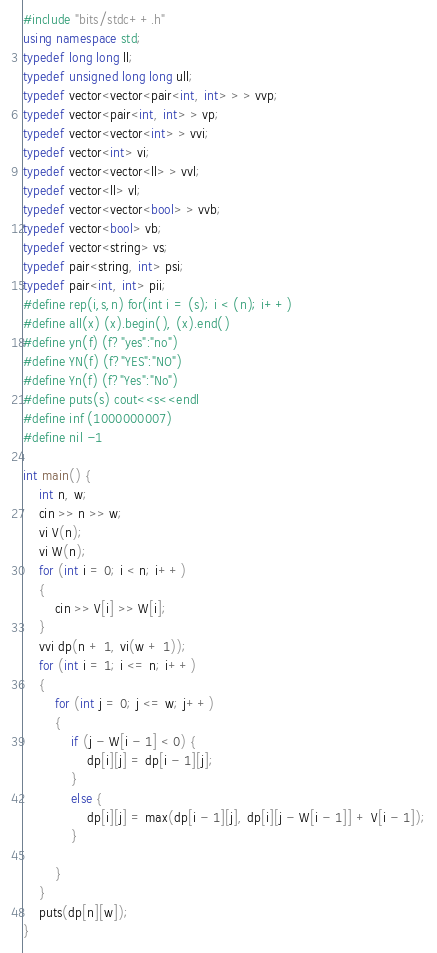Convert code to text. <code><loc_0><loc_0><loc_500><loc_500><_C++_>#include "bits/stdc++.h"
using namespace std;
typedef long long ll;
typedef unsigned long long ull;
typedef vector<vector<pair<int, int> > > vvp;
typedef vector<pair<int, int> > vp;
typedef vector<vector<int> > vvi;
typedef vector<int> vi;
typedef vector<vector<ll> > vvl;
typedef vector<ll> vl;
typedef vector<vector<bool> > vvb;
typedef vector<bool> vb;
typedef vector<string> vs;
typedef pair<string, int> psi;
typedef pair<int, int> pii;
#define rep(i,s,n) for(int i = (s); i < (n); i++)
#define all(x) (x).begin(), (x).end()
#define yn(f) (f?"yes":"no")
#define YN(f) (f?"YES":"NO")
#define Yn(f) (f?"Yes":"No")
#define puts(s) cout<<s<<endl
#define inf (1000000007)
#define nil -1

int main() {
	int n, w;
	cin >> n >> w;
	vi V(n);
	vi W(n);
	for (int i = 0; i < n; i++)
	{
		cin >> V[i] >> W[i];
	}
	vvi dp(n + 1, vi(w + 1));
	for (int i = 1; i <= n; i++)
	{
		for (int j = 0; j <= w; j++)
		{
			if (j - W[i - 1] < 0) {
				dp[i][j] = dp[i - 1][j];
			}
			else {
				dp[i][j] = max(dp[i - 1][j], dp[i][j - W[i - 1]] + V[i - 1]);
			}

		}
	}
	puts(dp[n][w]);
}

</code> 